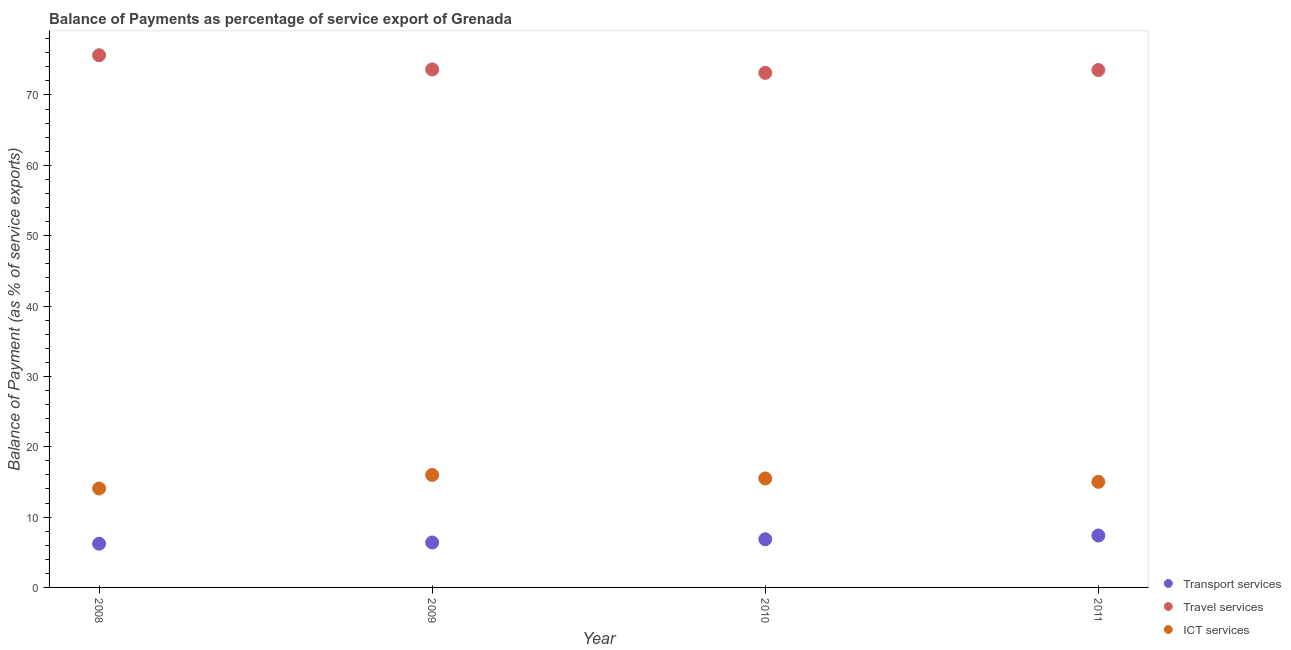How many different coloured dotlines are there?
Keep it short and to the point. 3. Is the number of dotlines equal to the number of legend labels?
Give a very brief answer. Yes. What is the balance of payment of ict services in 2008?
Provide a succinct answer. 14.06. Across all years, what is the maximum balance of payment of travel services?
Give a very brief answer. 75.65. Across all years, what is the minimum balance of payment of transport services?
Give a very brief answer. 6.22. In which year was the balance of payment of travel services minimum?
Provide a succinct answer. 2010. What is the total balance of payment of travel services in the graph?
Keep it short and to the point. 295.98. What is the difference between the balance of payment of travel services in 2008 and that in 2010?
Give a very brief answer. 2.51. What is the difference between the balance of payment of travel services in 2011 and the balance of payment of transport services in 2009?
Give a very brief answer. 67.16. What is the average balance of payment of travel services per year?
Your answer should be very brief. 73.99. In the year 2009, what is the difference between the balance of payment of ict services and balance of payment of transport services?
Give a very brief answer. 9.6. In how many years, is the balance of payment of transport services greater than 24 %?
Offer a very short reply. 0. What is the ratio of the balance of payment of transport services in 2008 to that in 2011?
Offer a very short reply. 0.84. Is the balance of payment of ict services in 2008 less than that in 2010?
Provide a succinct answer. Yes. Is the difference between the balance of payment of travel services in 2008 and 2011 greater than the difference between the balance of payment of ict services in 2008 and 2011?
Your answer should be compact. Yes. What is the difference between the highest and the second highest balance of payment of ict services?
Your answer should be very brief. 0.5. What is the difference between the highest and the lowest balance of payment of transport services?
Give a very brief answer. 1.16. In how many years, is the balance of payment of transport services greater than the average balance of payment of transport services taken over all years?
Give a very brief answer. 2. Is the sum of the balance of payment of ict services in 2008 and 2011 greater than the maximum balance of payment of travel services across all years?
Offer a very short reply. No. Is it the case that in every year, the sum of the balance of payment of transport services and balance of payment of travel services is greater than the balance of payment of ict services?
Provide a short and direct response. Yes. How many years are there in the graph?
Offer a terse response. 4. What is the difference between two consecutive major ticks on the Y-axis?
Ensure brevity in your answer.  10. Does the graph contain any zero values?
Your answer should be compact. No. Where does the legend appear in the graph?
Your response must be concise. Bottom right. What is the title of the graph?
Your answer should be very brief. Balance of Payments as percentage of service export of Grenada. Does "Private sector" appear as one of the legend labels in the graph?
Give a very brief answer. No. What is the label or title of the X-axis?
Offer a very short reply. Year. What is the label or title of the Y-axis?
Offer a very short reply. Balance of Payment (as % of service exports). What is the Balance of Payment (as % of service exports) in Transport services in 2008?
Give a very brief answer. 6.22. What is the Balance of Payment (as % of service exports) of Travel services in 2008?
Offer a very short reply. 75.65. What is the Balance of Payment (as % of service exports) of ICT services in 2008?
Give a very brief answer. 14.06. What is the Balance of Payment (as % of service exports) of Transport services in 2009?
Make the answer very short. 6.39. What is the Balance of Payment (as % of service exports) in Travel services in 2009?
Your answer should be very brief. 73.64. What is the Balance of Payment (as % of service exports) in ICT services in 2009?
Provide a short and direct response. 15.99. What is the Balance of Payment (as % of service exports) in Transport services in 2010?
Provide a short and direct response. 6.85. What is the Balance of Payment (as % of service exports) in Travel services in 2010?
Your response must be concise. 73.15. What is the Balance of Payment (as % of service exports) of ICT services in 2010?
Your response must be concise. 15.49. What is the Balance of Payment (as % of service exports) of Transport services in 2011?
Keep it short and to the point. 7.38. What is the Balance of Payment (as % of service exports) of Travel services in 2011?
Ensure brevity in your answer.  73.55. What is the Balance of Payment (as % of service exports) in ICT services in 2011?
Offer a terse response. 15.01. Across all years, what is the maximum Balance of Payment (as % of service exports) of Transport services?
Your response must be concise. 7.38. Across all years, what is the maximum Balance of Payment (as % of service exports) of Travel services?
Your answer should be compact. 75.65. Across all years, what is the maximum Balance of Payment (as % of service exports) in ICT services?
Give a very brief answer. 15.99. Across all years, what is the minimum Balance of Payment (as % of service exports) in Transport services?
Offer a terse response. 6.22. Across all years, what is the minimum Balance of Payment (as % of service exports) of Travel services?
Ensure brevity in your answer.  73.15. Across all years, what is the minimum Balance of Payment (as % of service exports) of ICT services?
Provide a short and direct response. 14.06. What is the total Balance of Payment (as % of service exports) in Transport services in the graph?
Make the answer very short. 26.84. What is the total Balance of Payment (as % of service exports) in Travel services in the graph?
Make the answer very short. 295.98. What is the total Balance of Payment (as % of service exports) in ICT services in the graph?
Offer a terse response. 60.54. What is the difference between the Balance of Payment (as % of service exports) in Transport services in 2008 and that in 2009?
Keep it short and to the point. -0.17. What is the difference between the Balance of Payment (as % of service exports) in Travel services in 2008 and that in 2009?
Ensure brevity in your answer.  2.01. What is the difference between the Balance of Payment (as % of service exports) in ICT services in 2008 and that in 2009?
Provide a succinct answer. -1.92. What is the difference between the Balance of Payment (as % of service exports) in Transport services in 2008 and that in 2010?
Your answer should be very brief. -0.63. What is the difference between the Balance of Payment (as % of service exports) in Travel services in 2008 and that in 2010?
Provide a succinct answer. 2.51. What is the difference between the Balance of Payment (as % of service exports) of ICT services in 2008 and that in 2010?
Make the answer very short. -1.43. What is the difference between the Balance of Payment (as % of service exports) in Transport services in 2008 and that in 2011?
Your answer should be very brief. -1.16. What is the difference between the Balance of Payment (as % of service exports) of Travel services in 2008 and that in 2011?
Provide a succinct answer. 2.1. What is the difference between the Balance of Payment (as % of service exports) of ICT services in 2008 and that in 2011?
Provide a succinct answer. -0.94. What is the difference between the Balance of Payment (as % of service exports) in Transport services in 2009 and that in 2010?
Your answer should be very brief. -0.46. What is the difference between the Balance of Payment (as % of service exports) of Travel services in 2009 and that in 2010?
Provide a succinct answer. 0.49. What is the difference between the Balance of Payment (as % of service exports) in ICT services in 2009 and that in 2010?
Your answer should be very brief. 0.5. What is the difference between the Balance of Payment (as % of service exports) in Transport services in 2009 and that in 2011?
Make the answer very short. -0.99. What is the difference between the Balance of Payment (as % of service exports) in Travel services in 2009 and that in 2011?
Ensure brevity in your answer.  0.09. What is the difference between the Balance of Payment (as % of service exports) in ICT services in 2009 and that in 2011?
Give a very brief answer. 0.98. What is the difference between the Balance of Payment (as % of service exports) in Transport services in 2010 and that in 2011?
Provide a short and direct response. -0.53. What is the difference between the Balance of Payment (as % of service exports) of Travel services in 2010 and that in 2011?
Your answer should be compact. -0.4. What is the difference between the Balance of Payment (as % of service exports) of ICT services in 2010 and that in 2011?
Provide a succinct answer. 0.48. What is the difference between the Balance of Payment (as % of service exports) of Transport services in 2008 and the Balance of Payment (as % of service exports) of Travel services in 2009?
Your answer should be very brief. -67.42. What is the difference between the Balance of Payment (as % of service exports) of Transport services in 2008 and the Balance of Payment (as % of service exports) of ICT services in 2009?
Your response must be concise. -9.76. What is the difference between the Balance of Payment (as % of service exports) of Travel services in 2008 and the Balance of Payment (as % of service exports) of ICT services in 2009?
Your answer should be very brief. 59.67. What is the difference between the Balance of Payment (as % of service exports) in Transport services in 2008 and the Balance of Payment (as % of service exports) in Travel services in 2010?
Provide a succinct answer. -66.92. What is the difference between the Balance of Payment (as % of service exports) in Transport services in 2008 and the Balance of Payment (as % of service exports) in ICT services in 2010?
Make the answer very short. -9.27. What is the difference between the Balance of Payment (as % of service exports) in Travel services in 2008 and the Balance of Payment (as % of service exports) in ICT services in 2010?
Your answer should be very brief. 60.16. What is the difference between the Balance of Payment (as % of service exports) in Transport services in 2008 and the Balance of Payment (as % of service exports) in Travel services in 2011?
Your response must be concise. -67.33. What is the difference between the Balance of Payment (as % of service exports) of Transport services in 2008 and the Balance of Payment (as % of service exports) of ICT services in 2011?
Offer a very short reply. -8.79. What is the difference between the Balance of Payment (as % of service exports) of Travel services in 2008 and the Balance of Payment (as % of service exports) of ICT services in 2011?
Provide a short and direct response. 60.64. What is the difference between the Balance of Payment (as % of service exports) in Transport services in 2009 and the Balance of Payment (as % of service exports) in Travel services in 2010?
Offer a terse response. -66.76. What is the difference between the Balance of Payment (as % of service exports) of Transport services in 2009 and the Balance of Payment (as % of service exports) of ICT services in 2010?
Ensure brevity in your answer.  -9.1. What is the difference between the Balance of Payment (as % of service exports) of Travel services in 2009 and the Balance of Payment (as % of service exports) of ICT services in 2010?
Offer a very short reply. 58.15. What is the difference between the Balance of Payment (as % of service exports) in Transport services in 2009 and the Balance of Payment (as % of service exports) in Travel services in 2011?
Your response must be concise. -67.16. What is the difference between the Balance of Payment (as % of service exports) in Transport services in 2009 and the Balance of Payment (as % of service exports) in ICT services in 2011?
Your answer should be very brief. -8.62. What is the difference between the Balance of Payment (as % of service exports) in Travel services in 2009 and the Balance of Payment (as % of service exports) in ICT services in 2011?
Give a very brief answer. 58.63. What is the difference between the Balance of Payment (as % of service exports) in Transport services in 2010 and the Balance of Payment (as % of service exports) in Travel services in 2011?
Give a very brief answer. -66.7. What is the difference between the Balance of Payment (as % of service exports) in Transport services in 2010 and the Balance of Payment (as % of service exports) in ICT services in 2011?
Your answer should be compact. -8.16. What is the difference between the Balance of Payment (as % of service exports) in Travel services in 2010 and the Balance of Payment (as % of service exports) in ICT services in 2011?
Give a very brief answer. 58.14. What is the average Balance of Payment (as % of service exports) in Transport services per year?
Your answer should be very brief. 6.71. What is the average Balance of Payment (as % of service exports) in Travel services per year?
Offer a very short reply. 73.99. What is the average Balance of Payment (as % of service exports) in ICT services per year?
Ensure brevity in your answer.  15.14. In the year 2008, what is the difference between the Balance of Payment (as % of service exports) of Transport services and Balance of Payment (as % of service exports) of Travel services?
Provide a succinct answer. -69.43. In the year 2008, what is the difference between the Balance of Payment (as % of service exports) of Transport services and Balance of Payment (as % of service exports) of ICT services?
Offer a terse response. -7.84. In the year 2008, what is the difference between the Balance of Payment (as % of service exports) of Travel services and Balance of Payment (as % of service exports) of ICT services?
Provide a short and direct response. 61.59. In the year 2009, what is the difference between the Balance of Payment (as % of service exports) of Transport services and Balance of Payment (as % of service exports) of Travel services?
Make the answer very short. -67.25. In the year 2009, what is the difference between the Balance of Payment (as % of service exports) of Transport services and Balance of Payment (as % of service exports) of ICT services?
Give a very brief answer. -9.6. In the year 2009, what is the difference between the Balance of Payment (as % of service exports) in Travel services and Balance of Payment (as % of service exports) in ICT services?
Offer a terse response. 57.65. In the year 2010, what is the difference between the Balance of Payment (as % of service exports) in Transport services and Balance of Payment (as % of service exports) in Travel services?
Offer a very short reply. -66.3. In the year 2010, what is the difference between the Balance of Payment (as % of service exports) of Transport services and Balance of Payment (as % of service exports) of ICT services?
Your answer should be compact. -8.64. In the year 2010, what is the difference between the Balance of Payment (as % of service exports) of Travel services and Balance of Payment (as % of service exports) of ICT services?
Keep it short and to the point. 57.66. In the year 2011, what is the difference between the Balance of Payment (as % of service exports) in Transport services and Balance of Payment (as % of service exports) in Travel services?
Your answer should be compact. -66.17. In the year 2011, what is the difference between the Balance of Payment (as % of service exports) in Transport services and Balance of Payment (as % of service exports) in ICT services?
Give a very brief answer. -7.63. In the year 2011, what is the difference between the Balance of Payment (as % of service exports) in Travel services and Balance of Payment (as % of service exports) in ICT services?
Make the answer very short. 58.54. What is the ratio of the Balance of Payment (as % of service exports) of Transport services in 2008 to that in 2009?
Keep it short and to the point. 0.97. What is the ratio of the Balance of Payment (as % of service exports) in Travel services in 2008 to that in 2009?
Keep it short and to the point. 1.03. What is the ratio of the Balance of Payment (as % of service exports) in ICT services in 2008 to that in 2009?
Make the answer very short. 0.88. What is the ratio of the Balance of Payment (as % of service exports) of Transport services in 2008 to that in 2010?
Make the answer very short. 0.91. What is the ratio of the Balance of Payment (as % of service exports) of Travel services in 2008 to that in 2010?
Ensure brevity in your answer.  1.03. What is the ratio of the Balance of Payment (as % of service exports) of ICT services in 2008 to that in 2010?
Provide a short and direct response. 0.91. What is the ratio of the Balance of Payment (as % of service exports) of Transport services in 2008 to that in 2011?
Provide a short and direct response. 0.84. What is the ratio of the Balance of Payment (as % of service exports) of Travel services in 2008 to that in 2011?
Keep it short and to the point. 1.03. What is the ratio of the Balance of Payment (as % of service exports) of ICT services in 2008 to that in 2011?
Your answer should be compact. 0.94. What is the ratio of the Balance of Payment (as % of service exports) in Transport services in 2009 to that in 2010?
Ensure brevity in your answer.  0.93. What is the ratio of the Balance of Payment (as % of service exports) of ICT services in 2009 to that in 2010?
Your answer should be very brief. 1.03. What is the ratio of the Balance of Payment (as % of service exports) of Transport services in 2009 to that in 2011?
Your answer should be very brief. 0.87. What is the ratio of the Balance of Payment (as % of service exports) of ICT services in 2009 to that in 2011?
Your answer should be compact. 1.07. What is the ratio of the Balance of Payment (as % of service exports) in Transport services in 2010 to that in 2011?
Offer a very short reply. 0.93. What is the ratio of the Balance of Payment (as % of service exports) in ICT services in 2010 to that in 2011?
Your answer should be compact. 1.03. What is the difference between the highest and the second highest Balance of Payment (as % of service exports) in Transport services?
Offer a terse response. 0.53. What is the difference between the highest and the second highest Balance of Payment (as % of service exports) of Travel services?
Make the answer very short. 2.01. What is the difference between the highest and the second highest Balance of Payment (as % of service exports) of ICT services?
Your answer should be very brief. 0.5. What is the difference between the highest and the lowest Balance of Payment (as % of service exports) of Transport services?
Give a very brief answer. 1.16. What is the difference between the highest and the lowest Balance of Payment (as % of service exports) of Travel services?
Provide a succinct answer. 2.51. What is the difference between the highest and the lowest Balance of Payment (as % of service exports) in ICT services?
Keep it short and to the point. 1.92. 